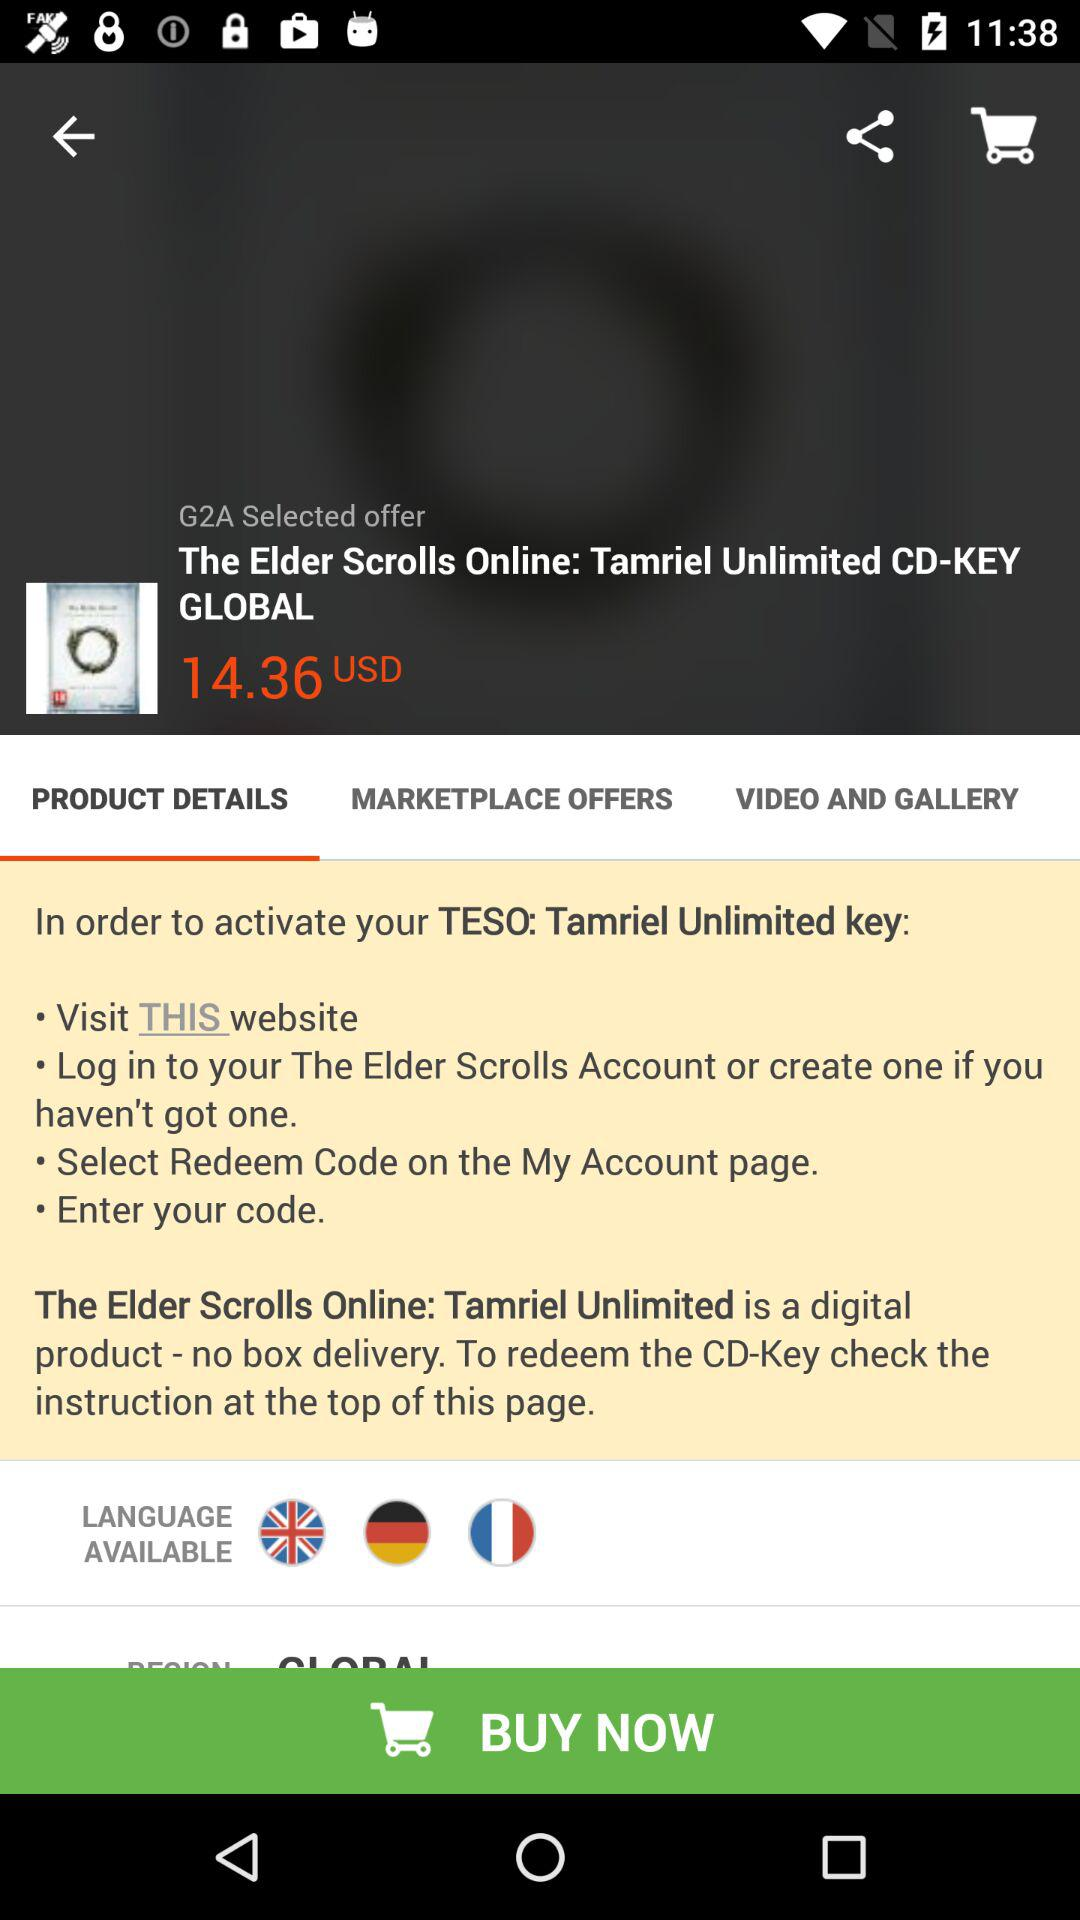What is the price of "Tamriel Unlimited CD-KEY GLOBAL"? The price is 14.36 USD. 